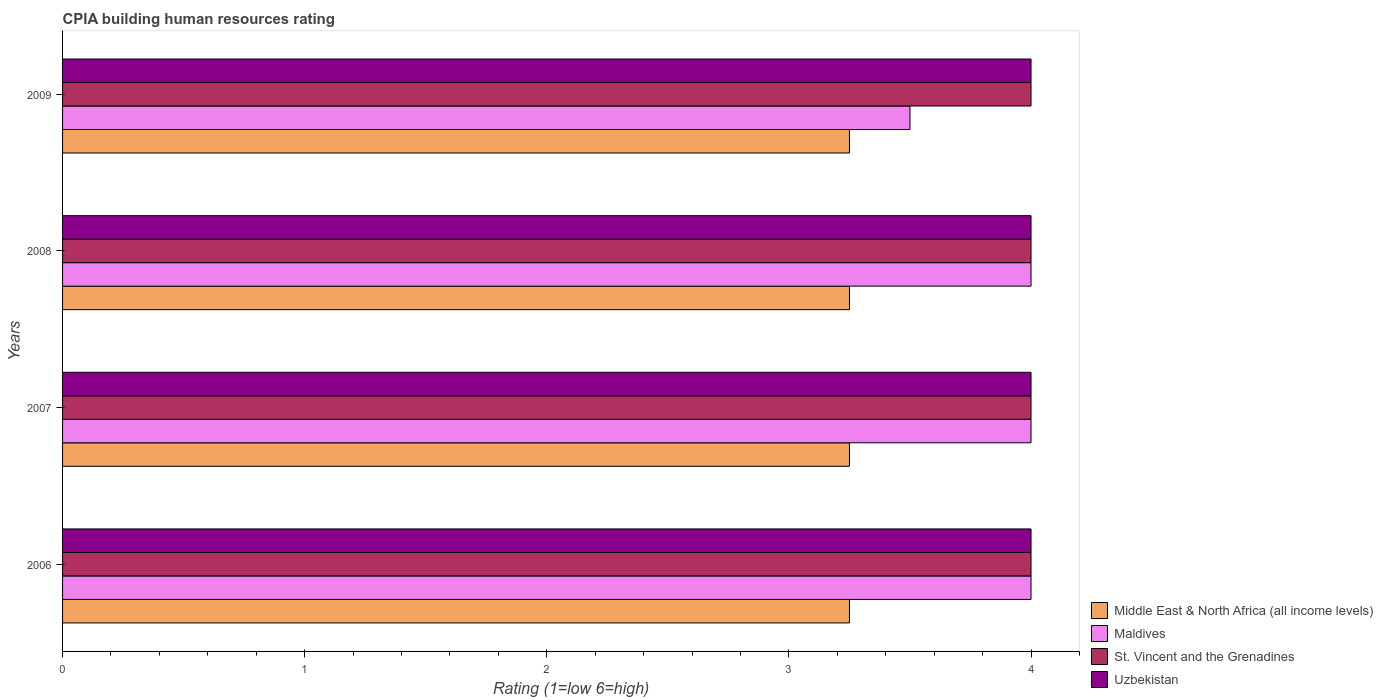How many different coloured bars are there?
Give a very brief answer. 4. How many groups of bars are there?
Ensure brevity in your answer.  4. How many bars are there on the 4th tick from the bottom?
Your answer should be compact. 4. What is the label of the 4th group of bars from the top?
Ensure brevity in your answer.  2006. In how many cases, is the number of bars for a given year not equal to the number of legend labels?
Ensure brevity in your answer.  0. What is the CPIA rating in Uzbekistan in 2008?
Your response must be concise. 4. Across all years, what is the maximum CPIA rating in Maldives?
Provide a short and direct response. 4. Across all years, what is the minimum CPIA rating in Uzbekistan?
Your answer should be very brief. 4. In which year was the CPIA rating in Middle East & North Africa (all income levels) maximum?
Your response must be concise. 2006. In which year was the CPIA rating in Maldives minimum?
Offer a terse response. 2009. What is the difference between the CPIA rating in St. Vincent and the Grenadines in 2006 and that in 2009?
Keep it short and to the point. 0. In the year 2007, what is the difference between the CPIA rating in St. Vincent and the Grenadines and CPIA rating in Middle East & North Africa (all income levels)?
Provide a succinct answer. 0.75. In how many years, is the CPIA rating in Uzbekistan greater than 2.2 ?
Keep it short and to the point. 4. Is the CPIA rating in St. Vincent and the Grenadines in 2007 less than that in 2008?
Make the answer very short. No. What is the difference between the highest and the lowest CPIA rating in Maldives?
Your answer should be very brief. 0.5. What does the 4th bar from the top in 2007 represents?
Offer a very short reply. Middle East & North Africa (all income levels). What does the 2nd bar from the bottom in 2008 represents?
Provide a short and direct response. Maldives. Are the values on the major ticks of X-axis written in scientific E-notation?
Keep it short and to the point. No. Does the graph contain grids?
Offer a very short reply. No. How are the legend labels stacked?
Your response must be concise. Vertical. What is the title of the graph?
Your answer should be very brief. CPIA building human resources rating. What is the label or title of the X-axis?
Provide a succinct answer. Rating (1=low 6=high). What is the Rating (1=low 6=high) of Middle East & North Africa (all income levels) in 2006?
Offer a terse response. 3.25. What is the Rating (1=low 6=high) of Uzbekistan in 2006?
Give a very brief answer. 4. What is the Rating (1=low 6=high) in Middle East & North Africa (all income levels) in 2007?
Provide a succinct answer. 3.25. What is the Rating (1=low 6=high) of St. Vincent and the Grenadines in 2007?
Your response must be concise. 4. What is the Rating (1=low 6=high) of Maldives in 2008?
Keep it short and to the point. 4. What is the Rating (1=low 6=high) of Middle East & North Africa (all income levels) in 2009?
Give a very brief answer. 3.25. What is the Rating (1=low 6=high) of Maldives in 2009?
Make the answer very short. 3.5. What is the Rating (1=low 6=high) of Uzbekistan in 2009?
Provide a short and direct response. 4. Across all years, what is the minimum Rating (1=low 6=high) of Maldives?
Ensure brevity in your answer.  3.5. Across all years, what is the minimum Rating (1=low 6=high) of St. Vincent and the Grenadines?
Offer a very short reply. 4. Across all years, what is the minimum Rating (1=low 6=high) of Uzbekistan?
Offer a very short reply. 4. What is the total Rating (1=low 6=high) of Maldives in the graph?
Your response must be concise. 15.5. What is the total Rating (1=low 6=high) of Uzbekistan in the graph?
Provide a succinct answer. 16. What is the difference between the Rating (1=low 6=high) in Middle East & North Africa (all income levels) in 2006 and that in 2007?
Your answer should be compact. 0. What is the difference between the Rating (1=low 6=high) in Maldives in 2006 and that in 2007?
Your response must be concise. 0. What is the difference between the Rating (1=low 6=high) in Maldives in 2006 and that in 2008?
Offer a terse response. 0. What is the difference between the Rating (1=low 6=high) in Uzbekistan in 2006 and that in 2008?
Provide a short and direct response. 0. What is the difference between the Rating (1=low 6=high) in Middle East & North Africa (all income levels) in 2006 and that in 2009?
Provide a short and direct response. 0. What is the difference between the Rating (1=low 6=high) in Middle East & North Africa (all income levels) in 2007 and that in 2008?
Your answer should be very brief. 0. What is the difference between the Rating (1=low 6=high) of Maldives in 2007 and that in 2008?
Give a very brief answer. 0. What is the difference between the Rating (1=low 6=high) of St. Vincent and the Grenadines in 2007 and that in 2008?
Your answer should be compact. 0. What is the difference between the Rating (1=low 6=high) in Uzbekistan in 2007 and that in 2008?
Your answer should be very brief. 0. What is the difference between the Rating (1=low 6=high) of St. Vincent and the Grenadines in 2007 and that in 2009?
Offer a terse response. 0. What is the difference between the Rating (1=low 6=high) in St. Vincent and the Grenadines in 2008 and that in 2009?
Keep it short and to the point. 0. What is the difference between the Rating (1=low 6=high) of Uzbekistan in 2008 and that in 2009?
Your answer should be compact. 0. What is the difference between the Rating (1=low 6=high) of Middle East & North Africa (all income levels) in 2006 and the Rating (1=low 6=high) of Maldives in 2007?
Your response must be concise. -0.75. What is the difference between the Rating (1=low 6=high) in Middle East & North Africa (all income levels) in 2006 and the Rating (1=low 6=high) in St. Vincent and the Grenadines in 2007?
Make the answer very short. -0.75. What is the difference between the Rating (1=low 6=high) of Middle East & North Africa (all income levels) in 2006 and the Rating (1=low 6=high) of Uzbekistan in 2007?
Give a very brief answer. -0.75. What is the difference between the Rating (1=low 6=high) of St. Vincent and the Grenadines in 2006 and the Rating (1=low 6=high) of Uzbekistan in 2007?
Your answer should be compact. 0. What is the difference between the Rating (1=low 6=high) in Middle East & North Africa (all income levels) in 2006 and the Rating (1=low 6=high) in Maldives in 2008?
Ensure brevity in your answer.  -0.75. What is the difference between the Rating (1=low 6=high) of Middle East & North Africa (all income levels) in 2006 and the Rating (1=low 6=high) of St. Vincent and the Grenadines in 2008?
Provide a succinct answer. -0.75. What is the difference between the Rating (1=low 6=high) of Middle East & North Africa (all income levels) in 2006 and the Rating (1=low 6=high) of Uzbekistan in 2008?
Offer a terse response. -0.75. What is the difference between the Rating (1=low 6=high) in Maldives in 2006 and the Rating (1=low 6=high) in St. Vincent and the Grenadines in 2008?
Offer a very short reply. 0. What is the difference between the Rating (1=low 6=high) of Maldives in 2006 and the Rating (1=low 6=high) of Uzbekistan in 2008?
Ensure brevity in your answer.  0. What is the difference between the Rating (1=low 6=high) of Middle East & North Africa (all income levels) in 2006 and the Rating (1=low 6=high) of St. Vincent and the Grenadines in 2009?
Keep it short and to the point. -0.75. What is the difference between the Rating (1=low 6=high) in Middle East & North Africa (all income levels) in 2006 and the Rating (1=low 6=high) in Uzbekistan in 2009?
Make the answer very short. -0.75. What is the difference between the Rating (1=low 6=high) of Maldives in 2006 and the Rating (1=low 6=high) of Uzbekistan in 2009?
Offer a very short reply. 0. What is the difference between the Rating (1=low 6=high) in St. Vincent and the Grenadines in 2006 and the Rating (1=low 6=high) in Uzbekistan in 2009?
Ensure brevity in your answer.  0. What is the difference between the Rating (1=low 6=high) of Middle East & North Africa (all income levels) in 2007 and the Rating (1=low 6=high) of Maldives in 2008?
Give a very brief answer. -0.75. What is the difference between the Rating (1=low 6=high) of Middle East & North Africa (all income levels) in 2007 and the Rating (1=low 6=high) of St. Vincent and the Grenadines in 2008?
Ensure brevity in your answer.  -0.75. What is the difference between the Rating (1=low 6=high) of Middle East & North Africa (all income levels) in 2007 and the Rating (1=low 6=high) of Uzbekistan in 2008?
Your response must be concise. -0.75. What is the difference between the Rating (1=low 6=high) in Maldives in 2007 and the Rating (1=low 6=high) in St. Vincent and the Grenadines in 2008?
Keep it short and to the point. 0. What is the difference between the Rating (1=low 6=high) of St. Vincent and the Grenadines in 2007 and the Rating (1=low 6=high) of Uzbekistan in 2008?
Your answer should be very brief. 0. What is the difference between the Rating (1=low 6=high) in Middle East & North Africa (all income levels) in 2007 and the Rating (1=low 6=high) in Maldives in 2009?
Provide a short and direct response. -0.25. What is the difference between the Rating (1=low 6=high) in Middle East & North Africa (all income levels) in 2007 and the Rating (1=low 6=high) in St. Vincent and the Grenadines in 2009?
Your answer should be very brief. -0.75. What is the difference between the Rating (1=low 6=high) in Middle East & North Africa (all income levels) in 2007 and the Rating (1=low 6=high) in Uzbekistan in 2009?
Your response must be concise. -0.75. What is the difference between the Rating (1=low 6=high) in Maldives in 2007 and the Rating (1=low 6=high) in St. Vincent and the Grenadines in 2009?
Provide a short and direct response. 0. What is the difference between the Rating (1=low 6=high) of Maldives in 2007 and the Rating (1=low 6=high) of Uzbekistan in 2009?
Your answer should be compact. 0. What is the difference between the Rating (1=low 6=high) in St. Vincent and the Grenadines in 2007 and the Rating (1=low 6=high) in Uzbekistan in 2009?
Make the answer very short. 0. What is the difference between the Rating (1=low 6=high) in Middle East & North Africa (all income levels) in 2008 and the Rating (1=low 6=high) in St. Vincent and the Grenadines in 2009?
Your answer should be very brief. -0.75. What is the difference between the Rating (1=low 6=high) in Middle East & North Africa (all income levels) in 2008 and the Rating (1=low 6=high) in Uzbekistan in 2009?
Your answer should be very brief. -0.75. What is the difference between the Rating (1=low 6=high) of Maldives in 2008 and the Rating (1=low 6=high) of St. Vincent and the Grenadines in 2009?
Provide a short and direct response. 0. What is the difference between the Rating (1=low 6=high) of St. Vincent and the Grenadines in 2008 and the Rating (1=low 6=high) of Uzbekistan in 2009?
Keep it short and to the point. 0. What is the average Rating (1=low 6=high) of Maldives per year?
Provide a succinct answer. 3.88. What is the average Rating (1=low 6=high) in Uzbekistan per year?
Offer a terse response. 4. In the year 2006, what is the difference between the Rating (1=low 6=high) of Middle East & North Africa (all income levels) and Rating (1=low 6=high) of Maldives?
Ensure brevity in your answer.  -0.75. In the year 2006, what is the difference between the Rating (1=low 6=high) in Middle East & North Africa (all income levels) and Rating (1=low 6=high) in St. Vincent and the Grenadines?
Keep it short and to the point. -0.75. In the year 2006, what is the difference between the Rating (1=low 6=high) of Middle East & North Africa (all income levels) and Rating (1=low 6=high) of Uzbekistan?
Provide a short and direct response. -0.75. In the year 2007, what is the difference between the Rating (1=low 6=high) of Middle East & North Africa (all income levels) and Rating (1=low 6=high) of Maldives?
Your response must be concise. -0.75. In the year 2007, what is the difference between the Rating (1=low 6=high) in Middle East & North Africa (all income levels) and Rating (1=low 6=high) in St. Vincent and the Grenadines?
Give a very brief answer. -0.75. In the year 2007, what is the difference between the Rating (1=low 6=high) of Middle East & North Africa (all income levels) and Rating (1=low 6=high) of Uzbekistan?
Keep it short and to the point. -0.75. In the year 2008, what is the difference between the Rating (1=low 6=high) of Middle East & North Africa (all income levels) and Rating (1=low 6=high) of Maldives?
Give a very brief answer. -0.75. In the year 2008, what is the difference between the Rating (1=low 6=high) of Middle East & North Africa (all income levels) and Rating (1=low 6=high) of St. Vincent and the Grenadines?
Give a very brief answer. -0.75. In the year 2008, what is the difference between the Rating (1=low 6=high) of Middle East & North Africa (all income levels) and Rating (1=low 6=high) of Uzbekistan?
Ensure brevity in your answer.  -0.75. In the year 2008, what is the difference between the Rating (1=low 6=high) in St. Vincent and the Grenadines and Rating (1=low 6=high) in Uzbekistan?
Make the answer very short. 0. In the year 2009, what is the difference between the Rating (1=low 6=high) of Middle East & North Africa (all income levels) and Rating (1=low 6=high) of Maldives?
Keep it short and to the point. -0.25. In the year 2009, what is the difference between the Rating (1=low 6=high) of Middle East & North Africa (all income levels) and Rating (1=low 6=high) of St. Vincent and the Grenadines?
Give a very brief answer. -0.75. In the year 2009, what is the difference between the Rating (1=low 6=high) in Middle East & North Africa (all income levels) and Rating (1=low 6=high) in Uzbekistan?
Your answer should be very brief. -0.75. In the year 2009, what is the difference between the Rating (1=low 6=high) in Maldives and Rating (1=low 6=high) in Uzbekistan?
Make the answer very short. -0.5. In the year 2009, what is the difference between the Rating (1=low 6=high) in St. Vincent and the Grenadines and Rating (1=low 6=high) in Uzbekistan?
Offer a very short reply. 0. What is the ratio of the Rating (1=low 6=high) in Uzbekistan in 2006 to that in 2007?
Make the answer very short. 1. What is the ratio of the Rating (1=low 6=high) in Maldives in 2006 to that in 2008?
Give a very brief answer. 1. What is the ratio of the Rating (1=low 6=high) in Uzbekistan in 2006 to that in 2008?
Keep it short and to the point. 1. What is the ratio of the Rating (1=low 6=high) of Middle East & North Africa (all income levels) in 2007 to that in 2008?
Your answer should be compact. 1. What is the ratio of the Rating (1=low 6=high) of St. Vincent and the Grenadines in 2007 to that in 2008?
Provide a short and direct response. 1. What is the ratio of the Rating (1=low 6=high) of Uzbekistan in 2007 to that in 2008?
Offer a terse response. 1. What is the ratio of the Rating (1=low 6=high) of Middle East & North Africa (all income levels) in 2007 to that in 2009?
Provide a succinct answer. 1. What is the ratio of the Rating (1=low 6=high) in Maldives in 2007 to that in 2009?
Your response must be concise. 1.14. What is the ratio of the Rating (1=low 6=high) in St. Vincent and the Grenadines in 2007 to that in 2009?
Ensure brevity in your answer.  1. What is the ratio of the Rating (1=low 6=high) in Uzbekistan in 2007 to that in 2009?
Offer a terse response. 1. What is the difference between the highest and the second highest Rating (1=low 6=high) of Middle East & North Africa (all income levels)?
Offer a terse response. 0. What is the difference between the highest and the second highest Rating (1=low 6=high) in St. Vincent and the Grenadines?
Offer a very short reply. 0. What is the difference between the highest and the lowest Rating (1=low 6=high) of Maldives?
Your answer should be compact. 0.5. What is the difference between the highest and the lowest Rating (1=low 6=high) in St. Vincent and the Grenadines?
Provide a short and direct response. 0. 